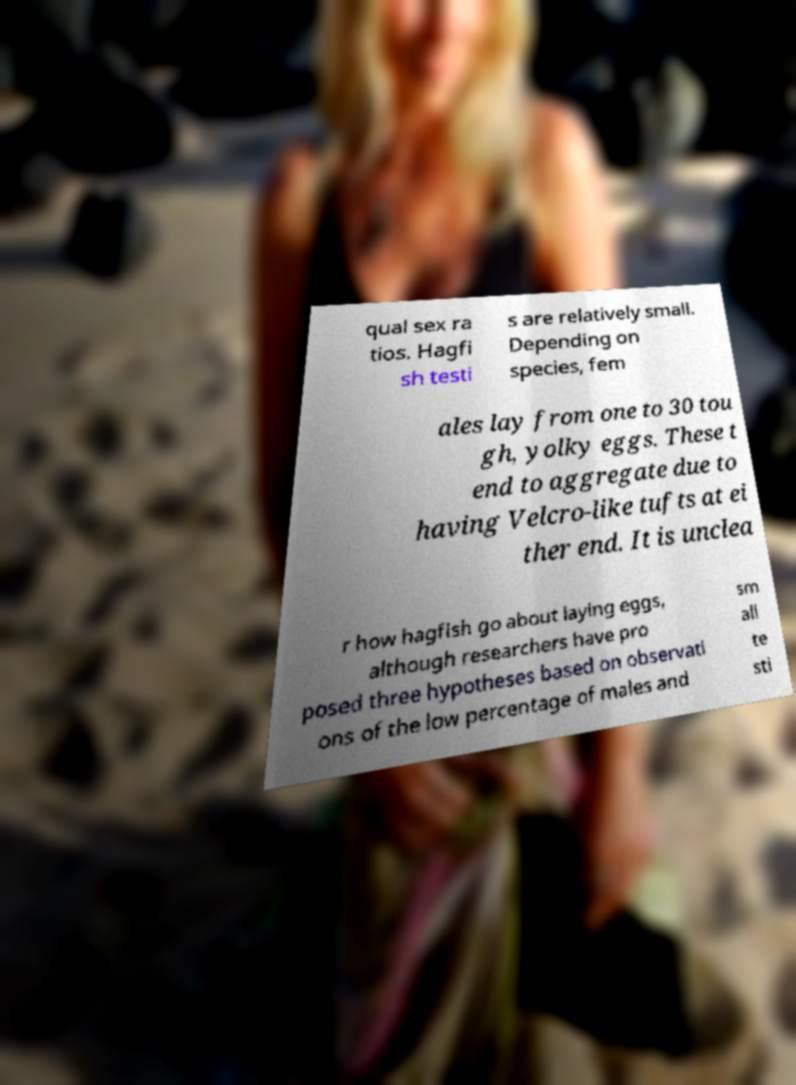Can you accurately transcribe the text from the provided image for me? qual sex ra tios. Hagfi sh testi s are relatively small. Depending on species, fem ales lay from one to 30 tou gh, yolky eggs. These t end to aggregate due to having Velcro-like tufts at ei ther end. It is unclea r how hagfish go about laying eggs, although researchers have pro posed three hypotheses based on observati ons of the low percentage of males and sm all te sti 